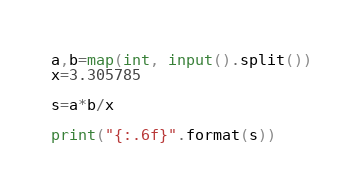Convert code to text. <code><loc_0><loc_0><loc_500><loc_500><_Python_>a,b=map(int, input().split())
x=3.305785

s=a*b/x

print("{:.6f}".format(s))
</code> 